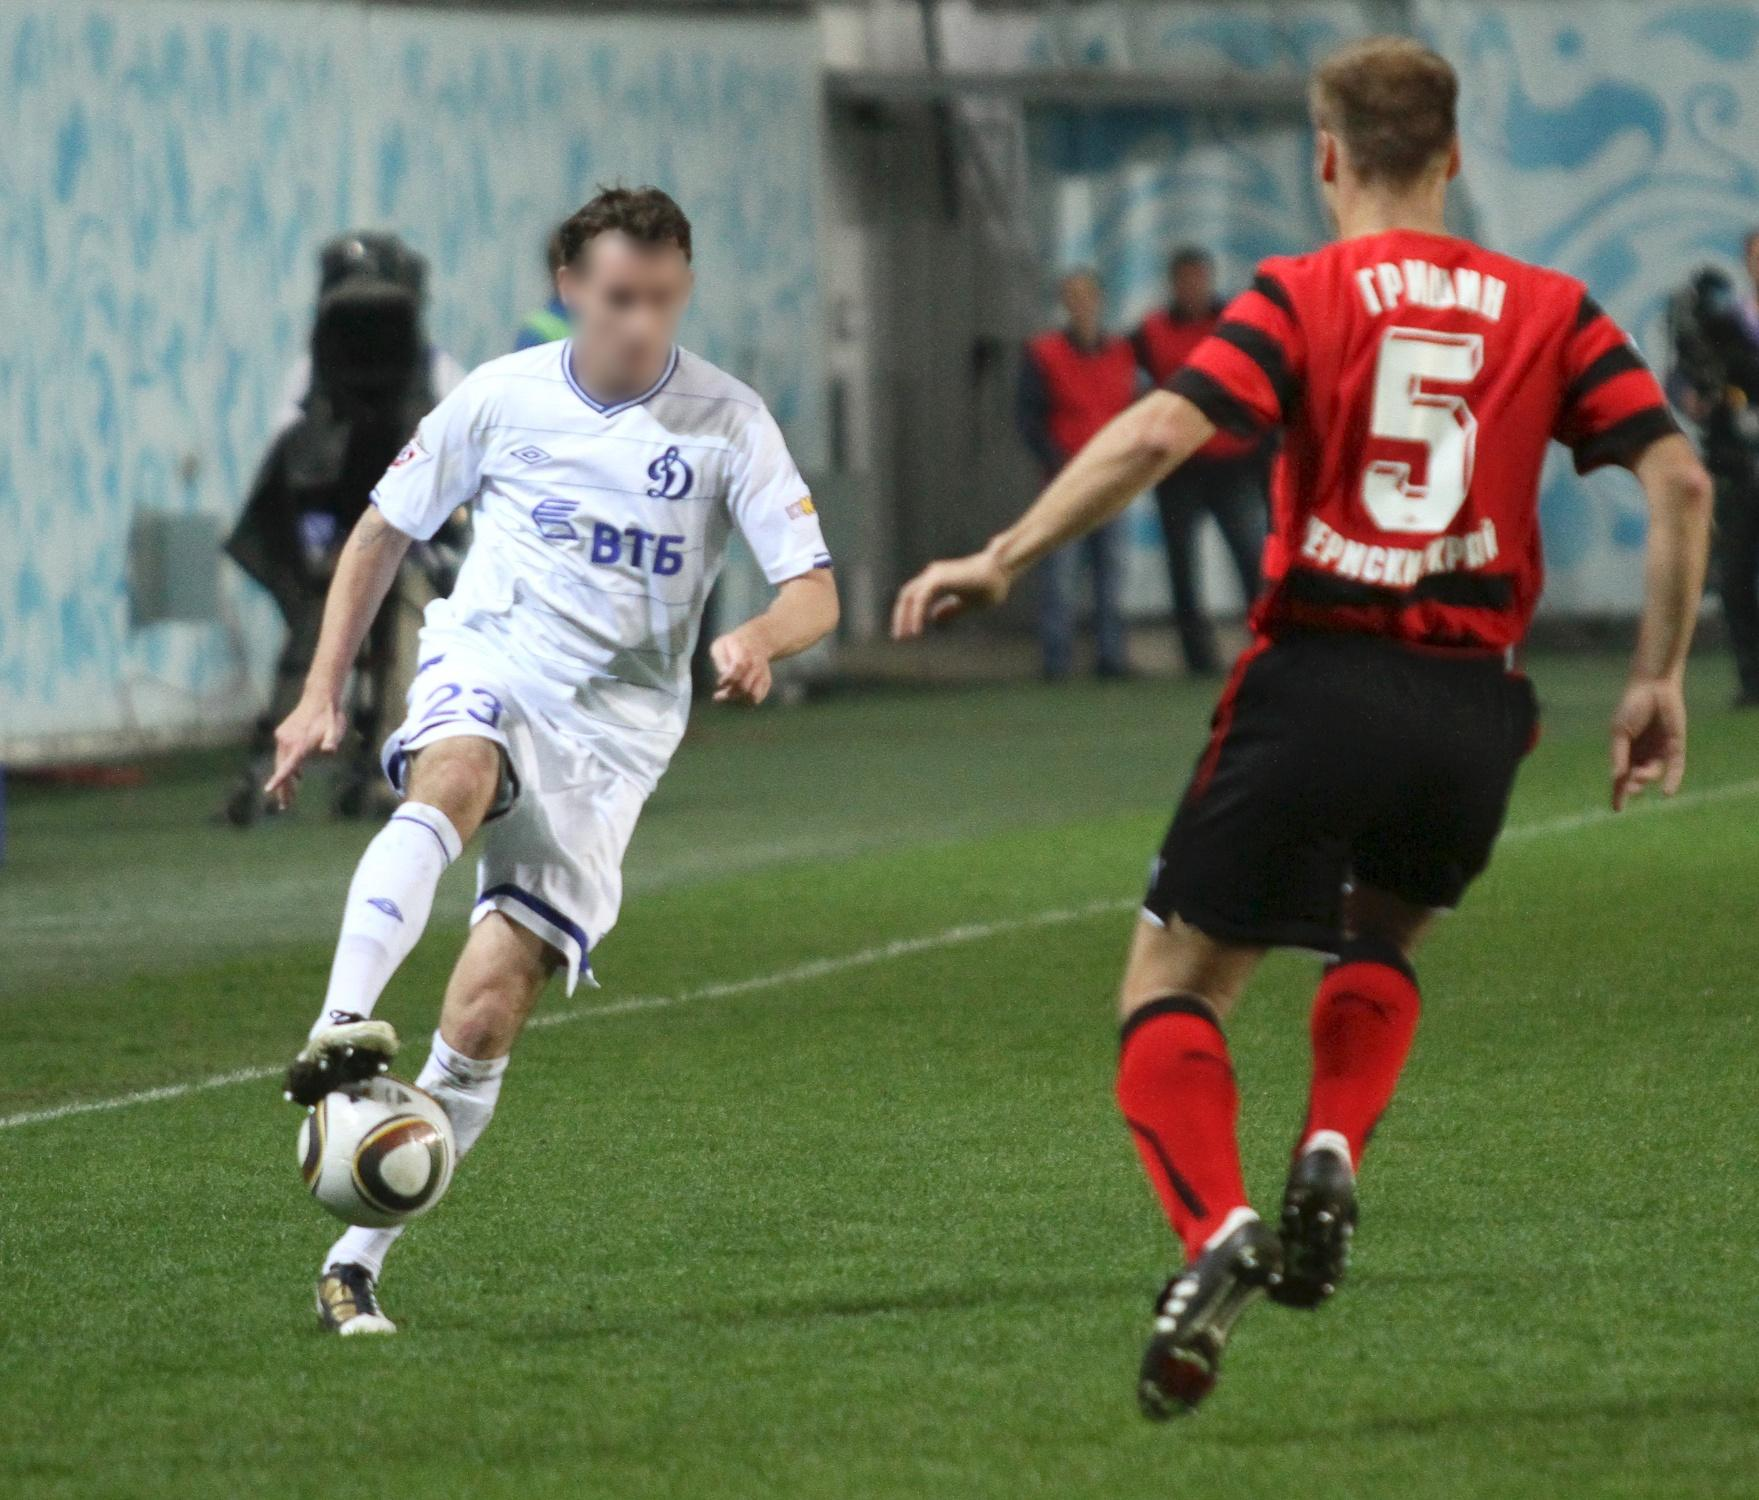Describe a potential backstory for the player in the white jersey. The player in the white jersey, number 23, is known as Alexei, a prodigious talent hailing from a small town on the outskirts of Moscow. From a young age, Alexei’s passion for soccer was evident, often seen dribbling makeshift balls in the narrow streets. His early years were marked by hardship as his family struggled financially, but it was Alexei's sheer talent and determination that caught the eye of local scouts. Over the years, he honed his skills and earned a reputation for his pace, agility, and sharp game sense. Balancing academics and soccer, Alexei became not only a star player in his school but also a beacon of hope for his community. His dedication paid off when he joined a prestigious soccer academy, eventually leading him to play for one of Russia's top clubs. Wearing jersey number 23, a tribute to his father who had to leave his soccer career for a stable job, Alexei plays each game with the determination to honor his family and inspire the next generation. His story is one of resilience, hope, and the relentless pursuit of dreams. Describe a potential backstory for the player in the red and black striped jersey. The player in the red and black striped jersey, number 5, is named Sergei. Sergei grew up in a rural village known for its strong community spirit and love for soccer. From an early age, he was recognized for his defensive prowess and strategic mind. Unlike many of his peers who idolized flashy forwards, Sergei admired legendary defenders, known for their tactical acumen and ability to read the game. His journey to professional soccer was paved with challenges and sacrifices. Coming from a family of farmers, Sergei balanced his physical chores with rigorous training. His dedication earned him a spot in a regional youth team, where his performances soon attracted national attention. Overcoming injuries and doubts, Sergei forged a path to the professional ranks, known for his relentless work ethic and composure under pressure. Wearing the number 5, he symbolizes the heart of his team's defense, embodying the spirit of his village and the lessons of perseverance taught by his family. Sergei's journey is a testament to the power of resilience, strategy, and community support. 